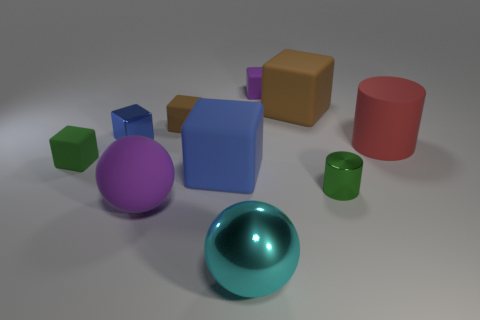The blue shiny thing that is the same shape as the small brown rubber object is what size?
Provide a succinct answer. Small. What number of other objects are the same size as the green rubber cube?
Make the answer very short. 4. Are there an equal number of cyan objects that are in front of the red matte cylinder and small matte objects?
Your response must be concise. No. Do the matte thing that is on the left side of the large purple sphere and the big matte cube on the right side of the purple cube have the same color?
Keep it short and to the point. No. What material is the small thing that is both in front of the blue shiny object and to the right of the blue rubber block?
Ensure brevity in your answer.  Metal. What is the color of the large cylinder?
Keep it short and to the point. Red. What number of other things are the same shape as the tiny brown object?
Make the answer very short. 5. Are there the same number of tiny objects that are on the left side of the large blue object and matte spheres that are behind the tiny green cylinder?
Your answer should be very brief. No. What material is the small purple block?
Offer a terse response. Rubber. There is a purple thing that is to the right of the tiny brown object; what is its material?
Keep it short and to the point. Rubber. 